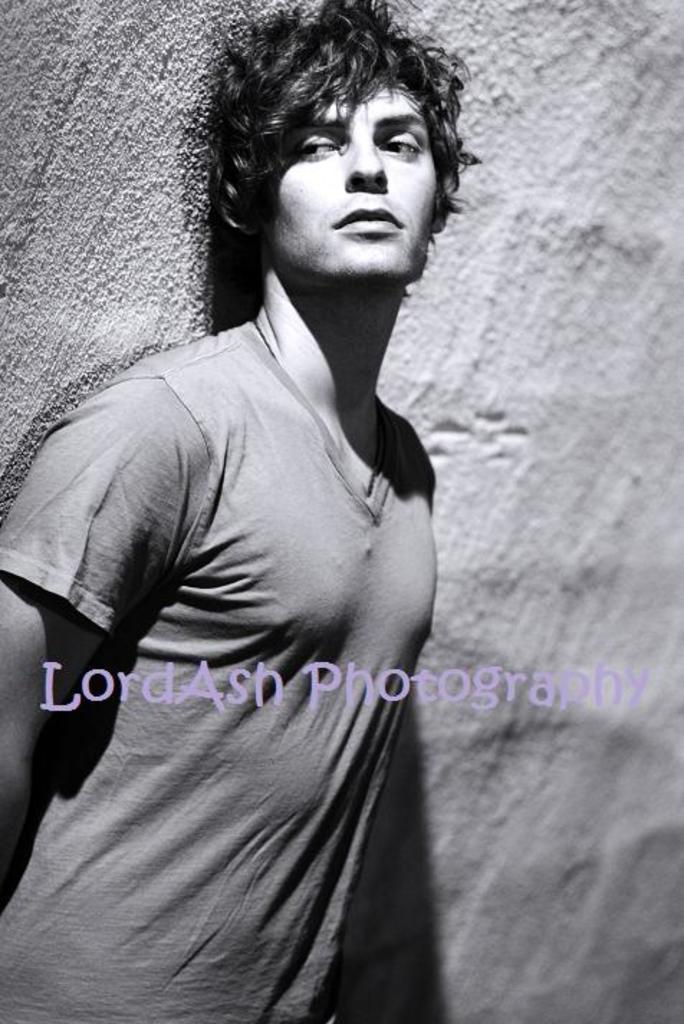Describe this image in one or two sentences. In the image there is a man wearing t-shirt standing in front of a wall, this is a black and white picture. 